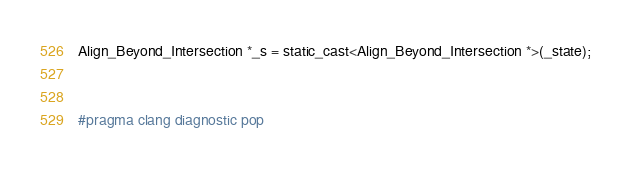Convert code to text. <code><loc_0><loc_0><loc_500><loc_500><_ObjectiveC_>Align_Beyond_Intersection *_s = static_cast<Align_Beyond_Intersection *>(_state);


#pragma clang diagnostic pop
</code> 